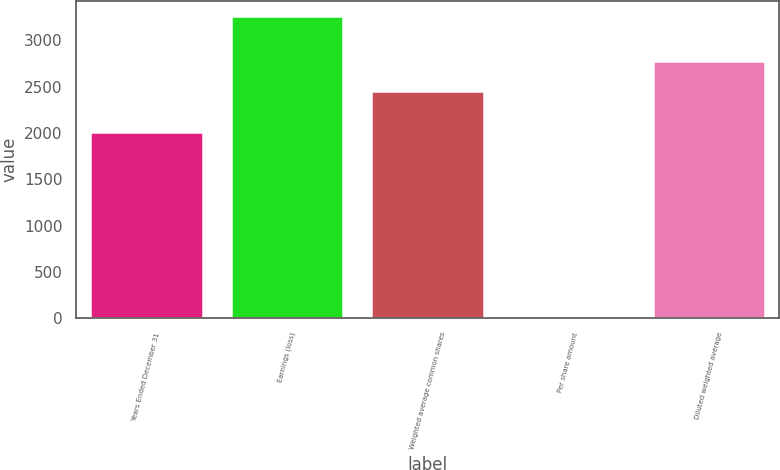Convert chart. <chart><loc_0><loc_0><loc_500><loc_500><bar_chart><fcel>Years Ended December 31<fcel>Earnings (loss)<fcel>Weighted average common shares<fcel>Per share amount<fcel>Diluted weighted average<nl><fcel>2006<fcel>3261<fcel>2446.3<fcel>1.33<fcel>2772.27<nl></chart> 